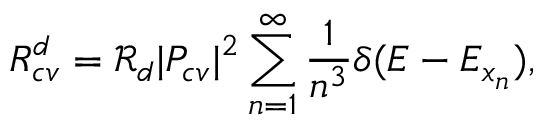<formula> <loc_0><loc_0><loc_500><loc_500>R _ { c v } ^ { d } = \mathcal { R } _ { d } | P _ { c v } | ^ { 2 } \sum _ { n = 1 } ^ { \infty } \frac { 1 } { n ^ { 3 } } \delta ( E - E _ { x _ { n } } ) ,</formula> 